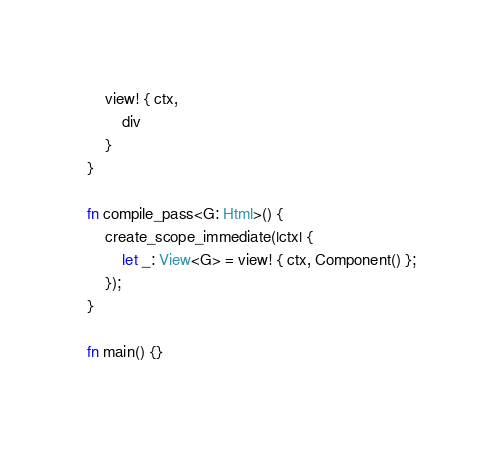Convert code to text. <code><loc_0><loc_0><loc_500><loc_500><_Rust_>    view! { ctx,
        div
    }
}

fn compile_pass<G: Html>() {
    create_scope_immediate(|ctx| {
        let _: View<G> = view! { ctx, Component() };
    });
}

fn main() {}
</code> 